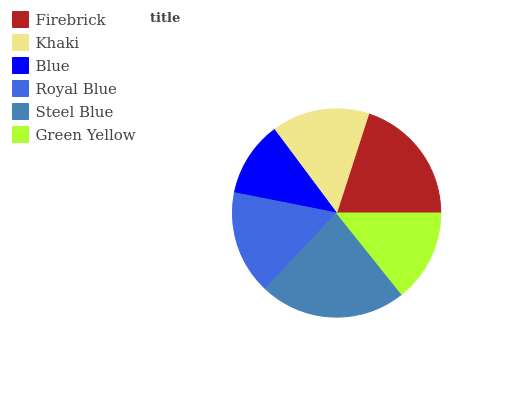Is Blue the minimum?
Answer yes or no. Yes. Is Steel Blue the maximum?
Answer yes or no. Yes. Is Khaki the minimum?
Answer yes or no. No. Is Khaki the maximum?
Answer yes or no. No. Is Firebrick greater than Khaki?
Answer yes or no. Yes. Is Khaki less than Firebrick?
Answer yes or no. Yes. Is Khaki greater than Firebrick?
Answer yes or no. No. Is Firebrick less than Khaki?
Answer yes or no. No. Is Royal Blue the high median?
Answer yes or no. Yes. Is Khaki the low median?
Answer yes or no. Yes. Is Firebrick the high median?
Answer yes or no. No. Is Green Yellow the low median?
Answer yes or no. No. 